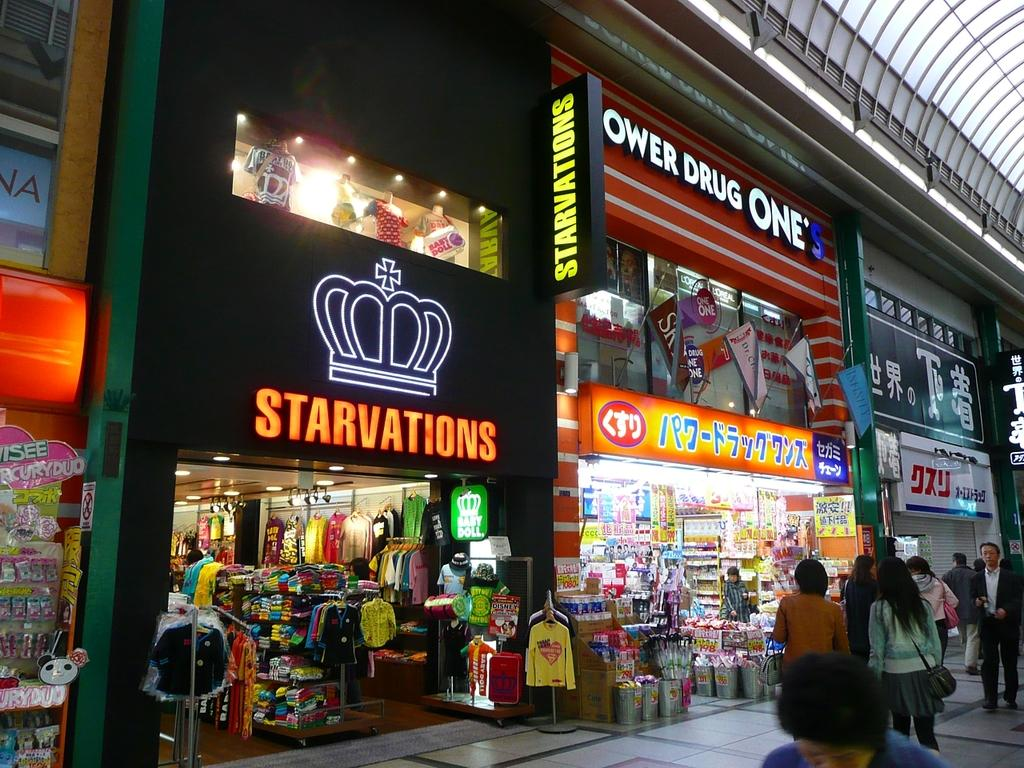<image>
Share a concise interpretation of the image provided. In a bright mall there is a store called starvations. 